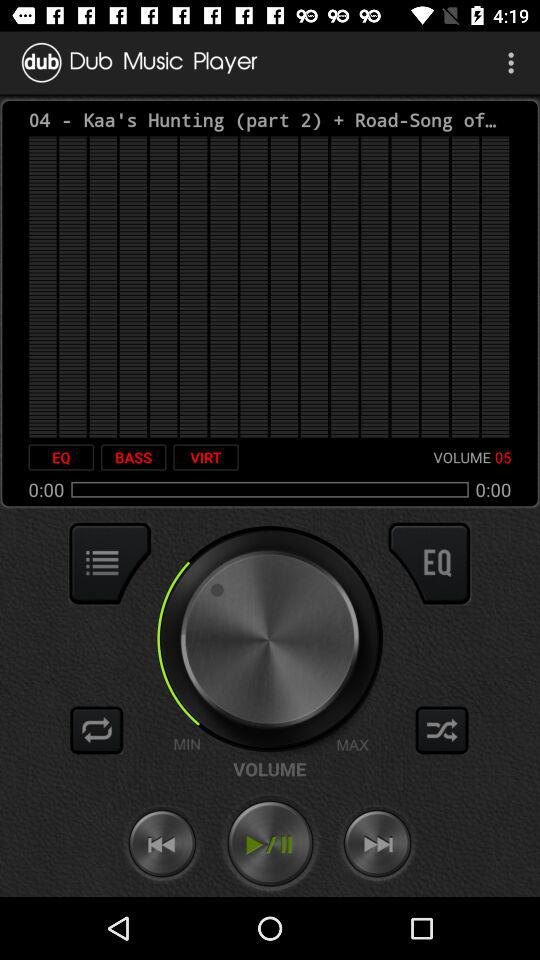Which song is currently playing?
When the provided information is insufficient, respond with <no answer>. <no answer> 